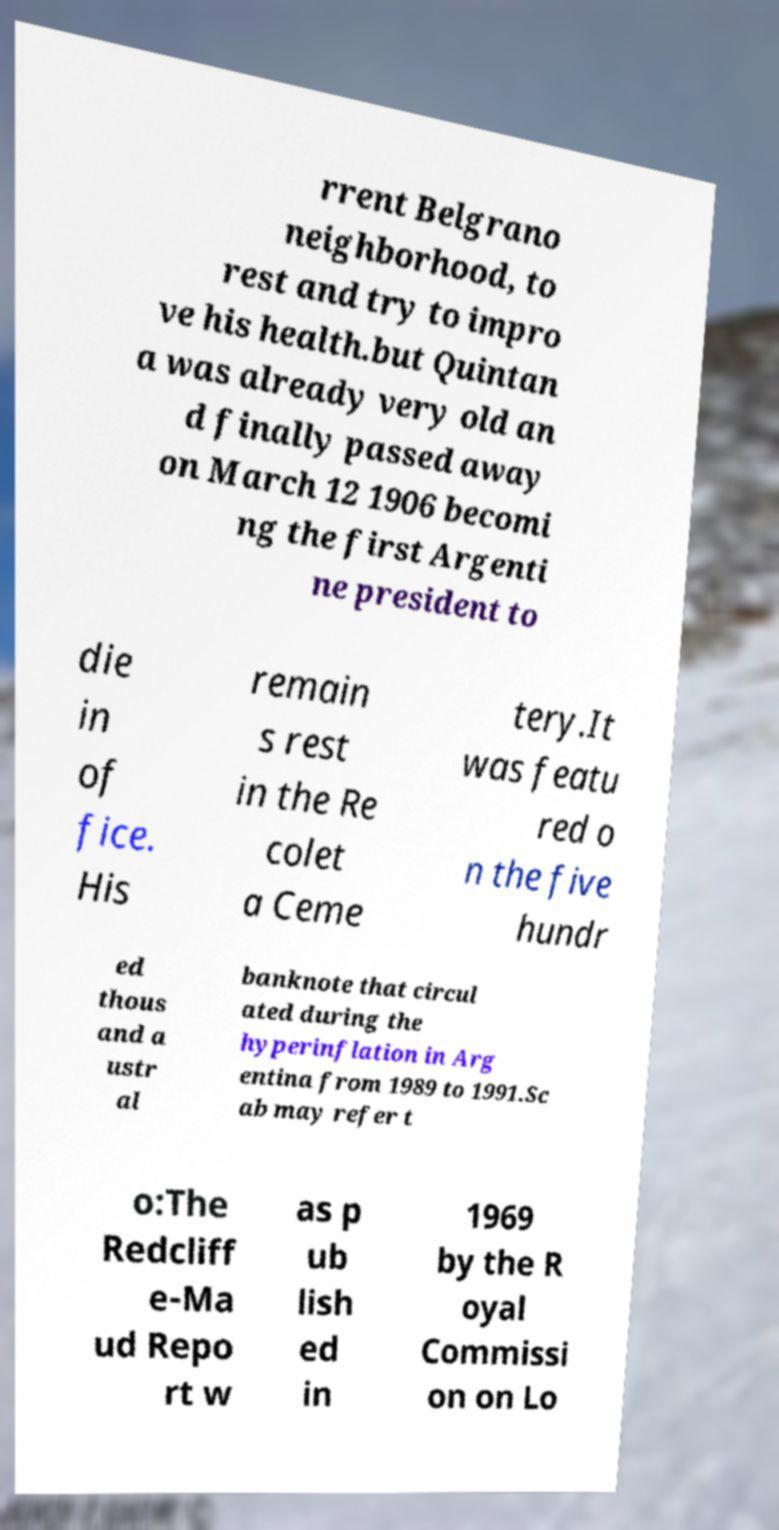Please identify and transcribe the text found in this image. rrent Belgrano neighborhood, to rest and try to impro ve his health.but Quintan a was already very old an d finally passed away on March 12 1906 becomi ng the first Argenti ne president to die in of fice. His remain s rest in the Re colet a Ceme tery.It was featu red o n the five hundr ed thous and a ustr al banknote that circul ated during the hyperinflation in Arg entina from 1989 to 1991.Sc ab may refer t o:The Redcliff e-Ma ud Repo rt w as p ub lish ed in 1969 by the R oyal Commissi on on Lo 